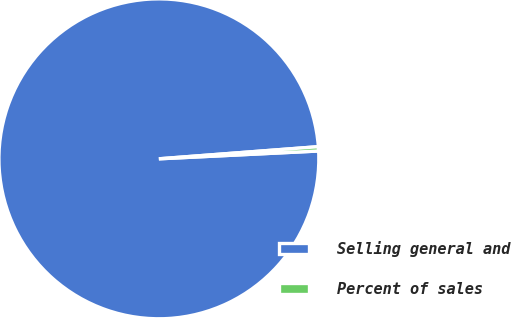Convert chart. <chart><loc_0><loc_0><loc_500><loc_500><pie_chart><fcel>Selling general and<fcel>Percent of sales<nl><fcel>99.57%<fcel>0.43%<nl></chart> 